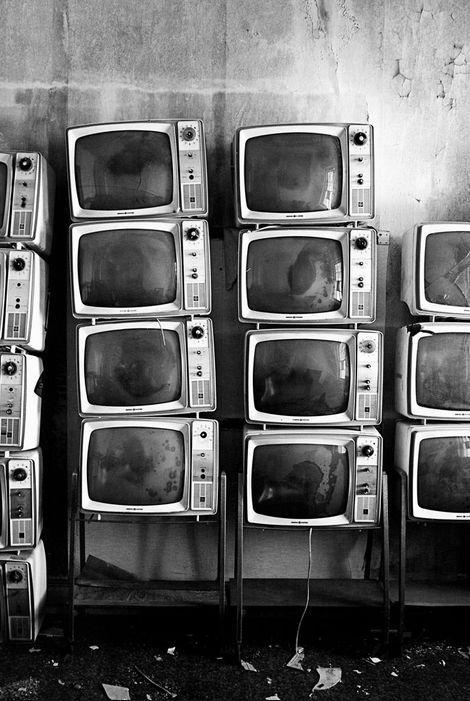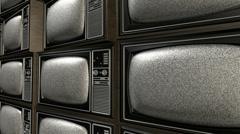The first image is the image on the left, the second image is the image on the right. Considering the images on both sides, is "At least one television's display is bright green." valid? Answer yes or no. No. The first image is the image on the left, the second image is the image on the right. Assess this claim about the two images: "The left image contains at least one old-fashioned TV with controls to the right of a slightly rounded square screen, which is glowing green.". Correct or not? Answer yes or no. No. 